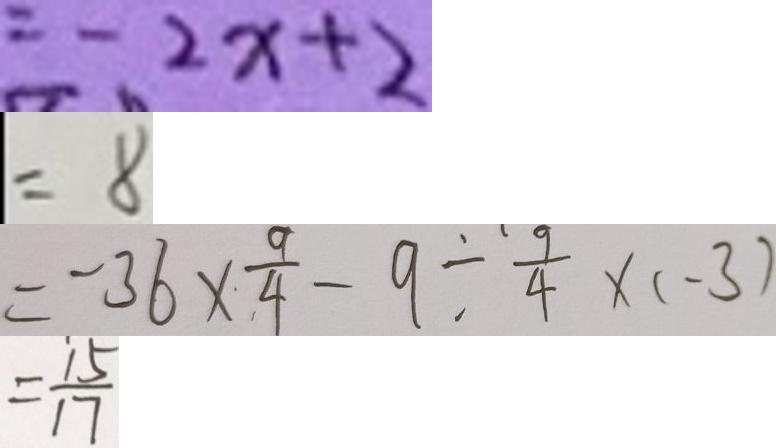<formula> <loc_0><loc_0><loc_500><loc_500>= - 2 x + 2 
 = 8 
 = - 3 6 \times \frac { 9 } { 4 } - 9 \div \frac { 9 } { 4 } \times ( - 3 ) 
 = \frac { 1 5 } { 1 7 }</formula> 